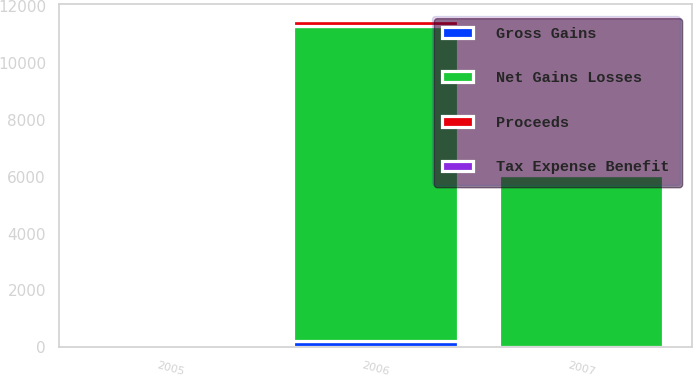<chart> <loc_0><loc_0><loc_500><loc_500><stacked_bar_chart><ecel><fcel>2007<fcel>2006<fcel>2005<nl><fcel>Net Gains Losses<fcel>6056<fcel>11102<fcel>41<nl><fcel>Tax Expense Benefit<fcel>20<fcel>2<fcel>19<nl><fcel>Gross Gains<fcel>25<fcel>209<fcel>60<nl><fcel>Proceeds<fcel>5<fcel>207<fcel>41<nl></chart> 